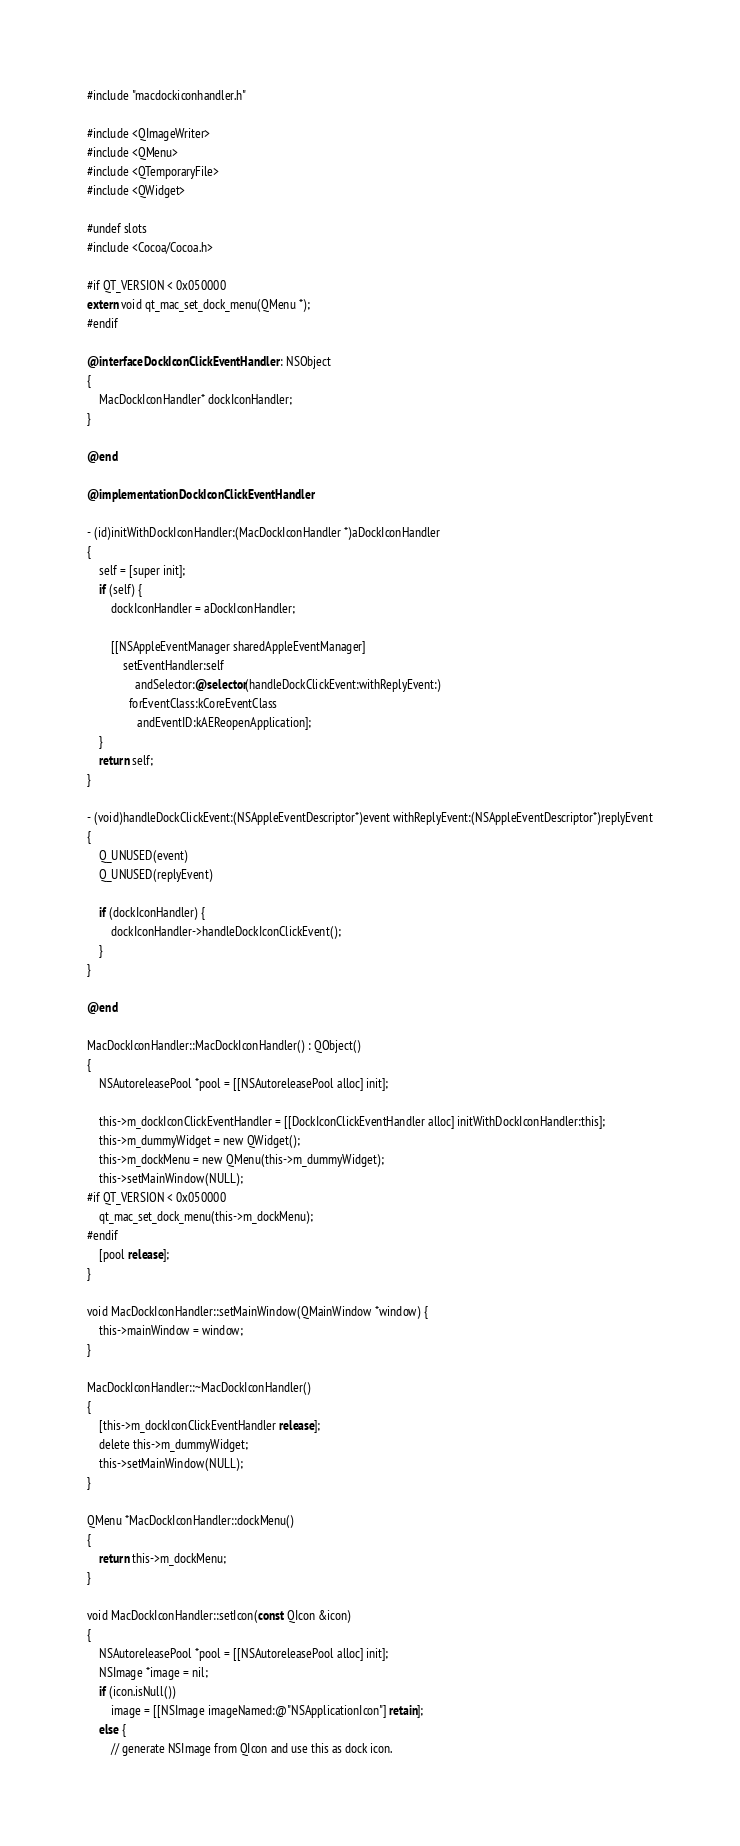Convert code to text. <code><loc_0><loc_0><loc_500><loc_500><_ObjectiveC_>#include "macdockiconhandler.h"

#include <QImageWriter>
#include <QMenu>
#include <QTemporaryFile>
#include <QWidget>

#undef slots
#include <Cocoa/Cocoa.h>

#if QT_VERSION < 0x050000
extern void qt_mac_set_dock_menu(QMenu *);
#endif

@interface DockIconClickEventHandler : NSObject
{
    MacDockIconHandler* dockIconHandler;
}

@end

@implementation DockIconClickEventHandler

- (id)initWithDockIconHandler:(MacDockIconHandler *)aDockIconHandler
{
    self = [super init];
    if (self) {
        dockIconHandler = aDockIconHandler;

        [[NSAppleEventManager sharedAppleEventManager]
            setEventHandler:self
                andSelector:@selector(handleDockClickEvent:withReplyEvent:)
              forEventClass:kCoreEventClass
                 andEventID:kAEReopenApplication];
    }
    return self;
}

- (void)handleDockClickEvent:(NSAppleEventDescriptor*)event withReplyEvent:(NSAppleEventDescriptor*)replyEvent
{
    Q_UNUSED(event)
    Q_UNUSED(replyEvent)

    if (dockIconHandler) {
        dockIconHandler->handleDockIconClickEvent();
    }
}

@end

MacDockIconHandler::MacDockIconHandler() : QObject()
{
    NSAutoreleasePool *pool = [[NSAutoreleasePool alloc] init];

    this->m_dockIconClickEventHandler = [[DockIconClickEventHandler alloc] initWithDockIconHandler:this];
    this->m_dummyWidget = new QWidget();
    this->m_dockMenu = new QMenu(this->m_dummyWidget);
    this->setMainWindow(NULL);
#if QT_VERSION < 0x050000
    qt_mac_set_dock_menu(this->m_dockMenu);
#endif
    [pool release];
}

void MacDockIconHandler::setMainWindow(QMainWindow *window) {
    this->mainWindow = window;
}

MacDockIconHandler::~MacDockIconHandler()
{
    [this->m_dockIconClickEventHandler release];
    delete this->m_dummyWidget;
    this->setMainWindow(NULL);
}

QMenu *MacDockIconHandler::dockMenu()
{
    return this->m_dockMenu;
}

void MacDockIconHandler::setIcon(const QIcon &icon)
{
    NSAutoreleasePool *pool = [[NSAutoreleasePool alloc] init];
    NSImage *image = nil;
    if (icon.isNull())
        image = [[NSImage imageNamed:@"NSApplicationIcon"] retain];
    else {
        // generate NSImage from QIcon and use this as dock icon.</code> 